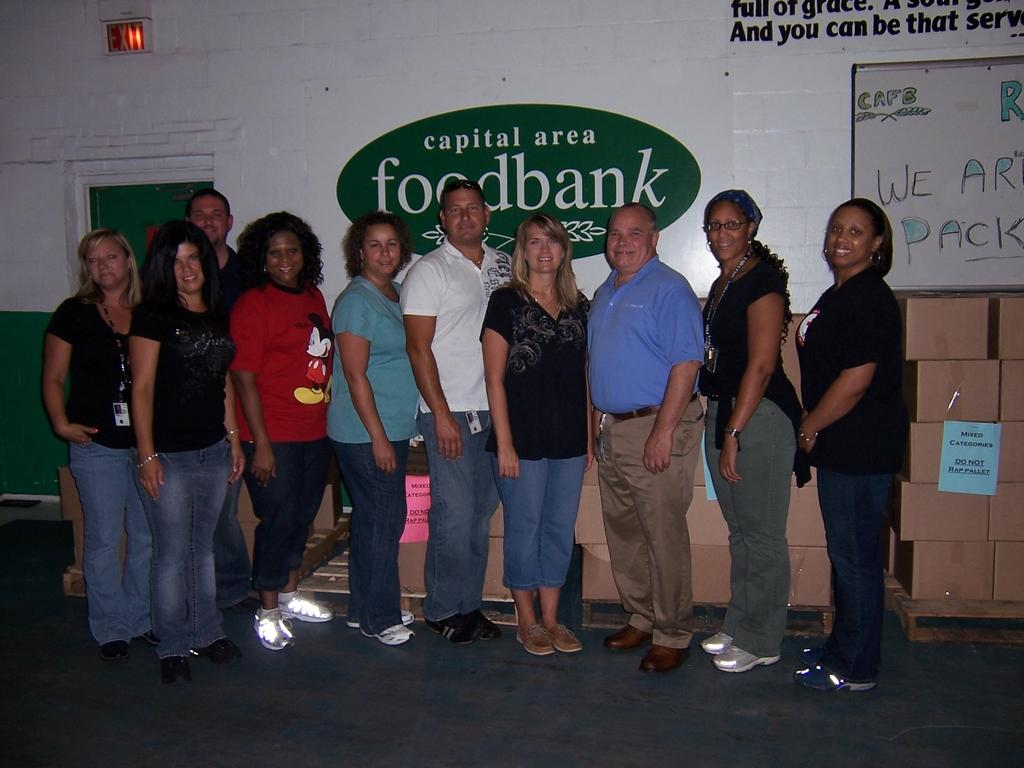How many people are in the image? There is a group of people in the image. What are the people doing in the image? The people are standing on the floor and smiling. What can be seen on the walls in the image? There are posters in the image. What is the purpose of the board in the image? The purpose of the board in the image is not specified, but it could be used for displaying information or as a surface for writing or drawing. What are the boxes in the image used for? The purpose of the boxes in the image is not specified, but they could be used for storage or transportation. What is visible in the background of the image? There is a door and a wall in the background of the image. What type of crops does the farmer in the image grow? There is no farmer present in the image, so it is not possible to answer that question. 